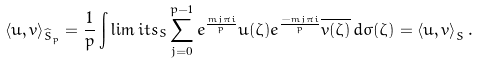<formula> <loc_0><loc_0><loc_500><loc_500>\left \langle u , v \right \rangle _ { \widehat { S } _ { p } } = \frac { 1 } { p } \int \lim i t s _ { S } \sum _ { j = 0 } ^ { p - 1 } e ^ { \frac { m j \pi i } { p } } u ( \zeta ) e ^ { \frac { - m j \pi i } { p } } \overline { v ( \zeta ) } \, d \sigma ( \zeta ) = \left \langle u , v \right \rangle _ { S } .</formula> 